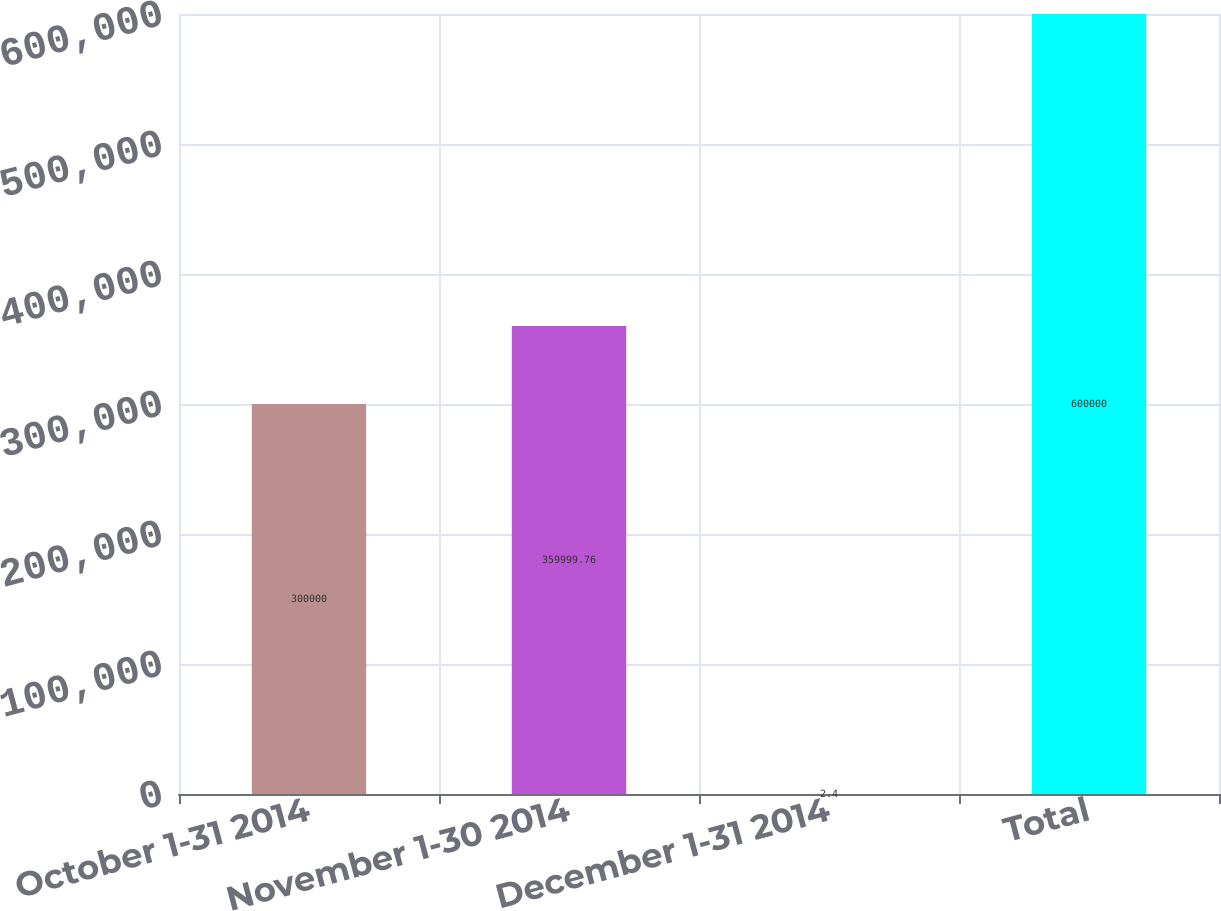Convert chart. <chart><loc_0><loc_0><loc_500><loc_500><bar_chart><fcel>October 1-31 2014<fcel>November 1-30 2014<fcel>December 1-31 2014<fcel>Total<nl><fcel>300000<fcel>360000<fcel>2.4<fcel>600000<nl></chart> 